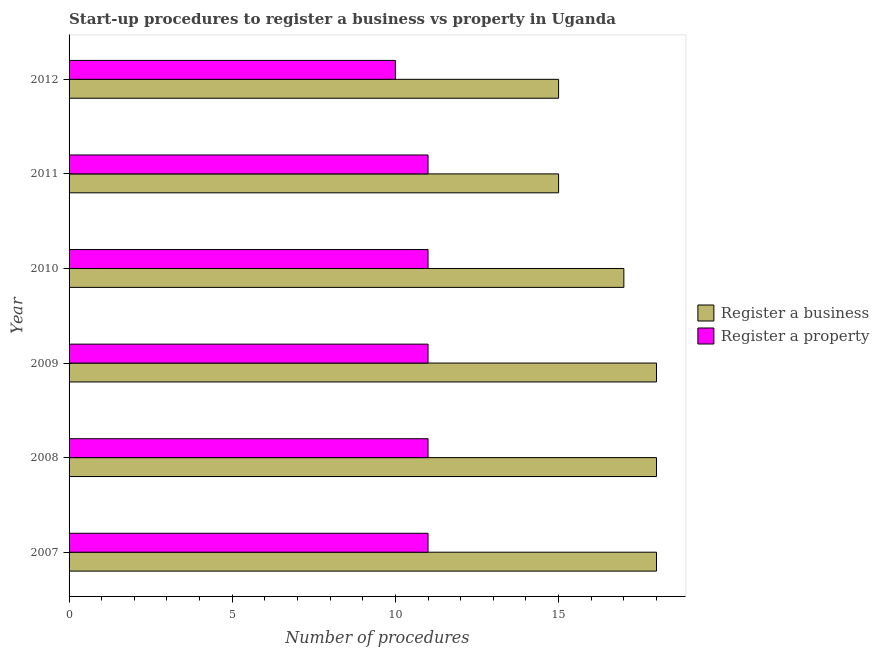How many bars are there on the 4th tick from the top?
Give a very brief answer. 2. How many bars are there on the 1st tick from the bottom?
Provide a succinct answer. 2. In how many cases, is the number of bars for a given year not equal to the number of legend labels?
Make the answer very short. 0. What is the number of procedures to register a property in 2010?
Provide a short and direct response. 11. Across all years, what is the maximum number of procedures to register a property?
Give a very brief answer. 11. Across all years, what is the minimum number of procedures to register a business?
Your answer should be compact. 15. What is the total number of procedures to register a property in the graph?
Offer a terse response. 65. What is the difference between the number of procedures to register a business in 2007 and that in 2009?
Give a very brief answer. 0. What is the difference between the number of procedures to register a business in 2009 and the number of procedures to register a property in 2011?
Your answer should be very brief. 7. What is the average number of procedures to register a property per year?
Offer a terse response. 10.83. In the year 2007, what is the difference between the number of procedures to register a property and number of procedures to register a business?
Offer a terse response. -7. In how many years, is the number of procedures to register a property greater than 5 ?
Ensure brevity in your answer.  6. What is the difference between the highest and the second highest number of procedures to register a business?
Provide a succinct answer. 0. What is the difference between the highest and the lowest number of procedures to register a business?
Your response must be concise. 3. Is the sum of the number of procedures to register a property in 2008 and 2011 greater than the maximum number of procedures to register a business across all years?
Offer a very short reply. Yes. What does the 2nd bar from the top in 2012 represents?
Keep it short and to the point. Register a business. What does the 1st bar from the bottom in 2011 represents?
Keep it short and to the point. Register a business. Are the values on the major ticks of X-axis written in scientific E-notation?
Provide a succinct answer. No. Does the graph contain any zero values?
Provide a short and direct response. No. Where does the legend appear in the graph?
Offer a very short reply. Center right. How many legend labels are there?
Make the answer very short. 2. What is the title of the graph?
Give a very brief answer. Start-up procedures to register a business vs property in Uganda. Does "Export" appear as one of the legend labels in the graph?
Ensure brevity in your answer.  No. What is the label or title of the X-axis?
Offer a terse response. Number of procedures. What is the label or title of the Y-axis?
Make the answer very short. Year. What is the Number of procedures in Register a property in 2007?
Make the answer very short. 11. What is the Number of procedures in Register a business in 2008?
Ensure brevity in your answer.  18. What is the Number of procedures of Register a property in 2009?
Provide a succinct answer. 11. What is the Number of procedures in Register a property in 2010?
Offer a terse response. 11. What is the Number of procedures in Register a business in 2011?
Your response must be concise. 15. What is the Number of procedures of Register a property in 2011?
Offer a very short reply. 11. What is the Number of procedures of Register a business in 2012?
Your response must be concise. 15. What is the Number of procedures of Register a property in 2012?
Provide a short and direct response. 10. Across all years, what is the maximum Number of procedures in Register a business?
Ensure brevity in your answer.  18. What is the total Number of procedures in Register a business in the graph?
Your response must be concise. 101. What is the total Number of procedures in Register a property in the graph?
Provide a short and direct response. 65. What is the difference between the Number of procedures in Register a business in 2007 and that in 2008?
Your answer should be compact. 0. What is the difference between the Number of procedures of Register a property in 2007 and that in 2008?
Make the answer very short. 0. What is the difference between the Number of procedures in Register a business in 2007 and that in 2009?
Ensure brevity in your answer.  0. What is the difference between the Number of procedures in Register a property in 2007 and that in 2009?
Your response must be concise. 0. What is the difference between the Number of procedures in Register a business in 2007 and that in 2010?
Offer a terse response. 1. What is the difference between the Number of procedures of Register a property in 2007 and that in 2011?
Your answer should be compact. 0. What is the difference between the Number of procedures in Register a property in 2008 and that in 2010?
Your answer should be compact. 0. What is the difference between the Number of procedures in Register a business in 2008 and that in 2011?
Offer a very short reply. 3. What is the difference between the Number of procedures of Register a property in 2008 and that in 2011?
Make the answer very short. 0. What is the difference between the Number of procedures of Register a business in 2008 and that in 2012?
Provide a succinct answer. 3. What is the difference between the Number of procedures in Register a property in 2008 and that in 2012?
Give a very brief answer. 1. What is the difference between the Number of procedures of Register a business in 2009 and that in 2010?
Offer a very short reply. 1. What is the difference between the Number of procedures of Register a property in 2009 and that in 2010?
Make the answer very short. 0. What is the difference between the Number of procedures of Register a business in 2009 and that in 2011?
Your answer should be very brief. 3. What is the difference between the Number of procedures of Register a property in 2009 and that in 2011?
Make the answer very short. 0. What is the difference between the Number of procedures of Register a property in 2009 and that in 2012?
Provide a succinct answer. 1. What is the difference between the Number of procedures of Register a business in 2010 and that in 2012?
Ensure brevity in your answer.  2. What is the difference between the Number of procedures of Register a property in 2010 and that in 2012?
Ensure brevity in your answer.  1. What is the difference between the Number of procedures in Register a business in 2011 and that in 2012?
Ensure brevity in your answer.  0. What is the difference between the Number of procedures of Register a business in 2007 and the Number of procedures of Register a property in 2008?
Provide a short and direct response. 7. What is the difference between the Number of procedures in Register a business in 2007 and the Number of procedures in Register a property in 2009?
Provide a succinct answer. 7. What is the difference between the Number of procedures of Register a business in 2007 and the Number of procedures of Register a property in 2010?
Offer a terse response. 7. What is the difference between the Number of procedures of Register a business in 2007 and the Number of procedures of Register a property in 2011?
Ensure brevity in your answer.  7. What is the difference between the Number of procedures in Register a business in 2008 and the Number of procedures in Register a property in 2010?
Give a very brief answer. 7. What is the difference between the Number of procedures of Register a business in 2008 and the Number of procedures of Register a property in 2011?
Keep it short and to the point. 7. What is the difference between the Number of procedures in Register a business in 2008 and the Number of procedures in Register a property in 2012?
Offer a very short reply. 8. What is the difference between the Number of procedures of Register a business in 2009 and the Number of procedures of Register a property in 2010?
Provide a short and direct response. 7. What is the difference between the Number of procedures of Register a business in 2009 and the Number of procedures of Register a property in 2012?
Give a very brief answer. 8. What is the difference between the Number of procedures of Register a business in 2010 and the Number of procedures of Register a property in 2011?
Your response must be concise. 6. What is the difference between the Number of procedures in Register a business in 2010 and the Number of procedures in Register a property in 2012?
Give a very brief answer. 7. What is the average Number of procedures of Register a business per year?
Give a very brief answer. 16.83. What is the average Number of procedures of Register a property per year?
Give a very brief answer. 10.83. In the year 2007, what is the difference between the Number of procedures of Register a business and Number of procedures of Register a property?
Give a very brief answer. 7. In the year 2009, what is the difference between the Number of procedures in Register a business and Number of procedures in Register a property?
Keep it short and to the point. 7. In the year 2011, what is the difference between the Number of procedures in Register a business and Number of procedures in Register a property?
Offer a terse response. 4. In the year 2012, what is the difference between the Number of procedures in Register a business and Number of procedures in Register a property?
Your response must be concise. 5. What is the ratio of the Number of procedures in Register a business in 2007 to that in 2009?
Your answer should be very brief. 1. What is the ratio of the Number of procedures of Register a property in 2007 to that in 2009?
Your answer should be very brief. 1. What is the ratio of the Number of procedures in Register a business in 2007 to that in 2010?
Provide a short and direct response. 1.06. What is the ratio of the Number of procedures of Register a property in 2007 to that in 2010?
Your answer should be compact. 1. What is the ratio of the Number of procedures in Register a property in 2007 to that in 2011?
Your response must be concise. 1. What is the ratio of the Number of procedures in Register a property in 2007 to that in 2012?
Your answer should be compact. 1.1. What is the ratio of the Number of procedures of Register a business in 2008 to that in 2009?
Keep it short and to the point. 1. What is the ratio of the Number of procedures of Register a property in 2008 to that in 2009?
Ensure brevity in your answer.  1. What is the ratio of the Number of procedures of Register a business in 2008 to that in 2010?
Provide a succinct answer. 1.06. What is the ratio of the Number of procedures in Register a business in 2009 to that in 2010?
Keep it short and to the point. 1.06. What is the ratio of the Number of procedures of Register a property in 2009 to that in 2010?
Offer a very short reply. 1. What is the ratio of the Number of procedures of Register a property in 2009 to that in 2011?
Provide a short and direct response. 1. What is the ratio of the Number of procedures in Register a property in 2009 to that in 2012?
Your response must be concise. 1.1. What is the ratio of the Number of procedures of Register a business in 2010 to that in 2011?
Give a very brief answer. 1.13. What is the ratio of the Number of procedures of Register a property in 2010 to that in 2011?
Give a very brief answer. 1. What is the ratio of the Number of procedures in Register a business in 2010 to that in 2012?
Give a very brief answer. 1.13. What is the ratio of the Number of procedures of Register a property in 2010 to that in 2012?
Keep it short and to the point. 1.1. What is the ratio of the Number of procedures in Register a business in 2011 to that in 2012?
Ensure brevity in your answer.  1. What is the difference between the highest and the second highest Number of procedures in Register a business?
Your answer should be very brief. 0. What is the difference between the highest and the second highest Number of procedures of Register a property?
Offer a very short reply. 0. What is the difference between the highest and the lowest Number of procedures in Register a property?
Provide a succinct answer. 1. 